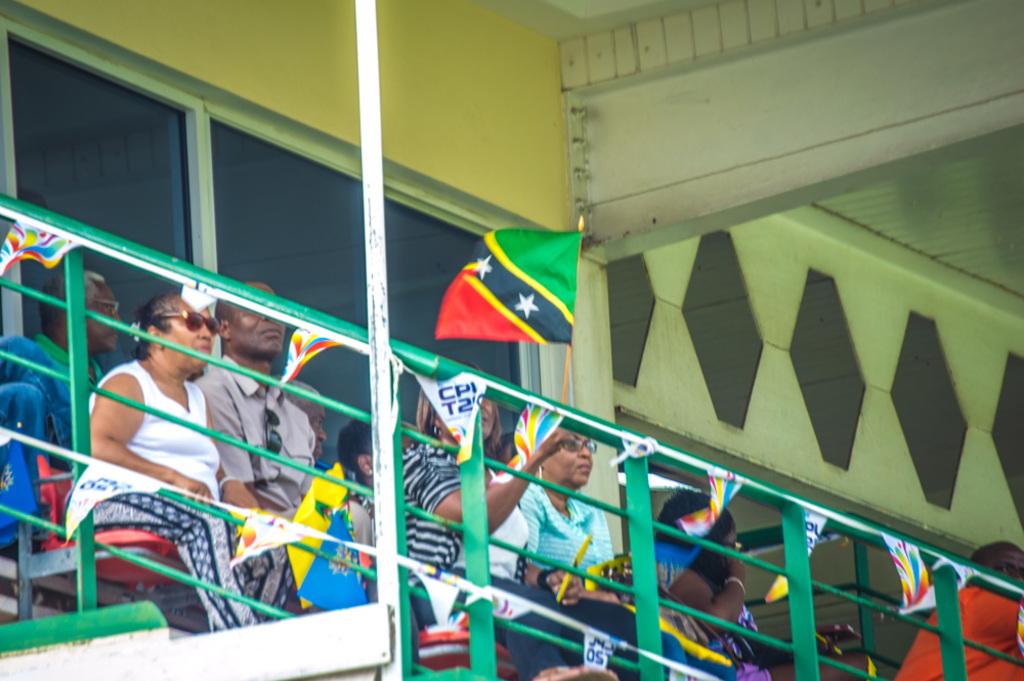What number is on the upsode down flag in the middle of the picture at the bottom?
Give a very brief answer. 50. 